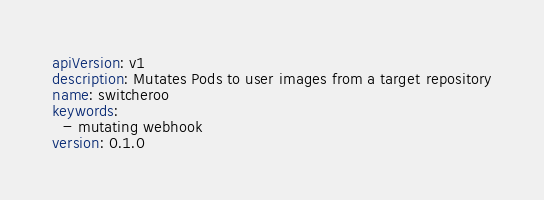<code> <loc_0><loc_0><loc_500><loc_500><_YAML_>apiVersion: v1
description: Mutates Pods to user images from a target repository
name: switcheroo
keywords:
  - mutating webhook
version: 0.1.0
</code> 